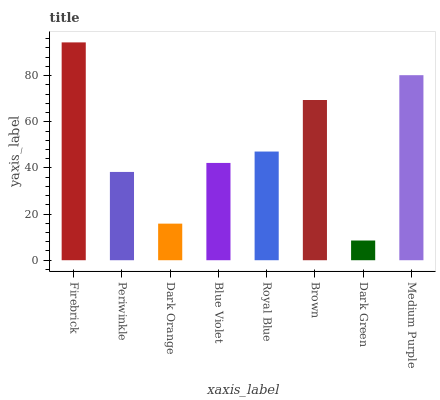Is Dark Green the minimum?
Answer yes or no. Yes. Is Firebrick the maximum?
Answer yes or no. Yes. Is Periwinkle the minimum?
Answer yes or no. No. Is Periwinkle the maximum?
Answer yes or no. No. Is Firebrick greater than Periwinkle?
Answer yes or no. Yes. Is Periwinkle less than Firebrick?
Answer yes or no. Yes. Is Periwinkle greater than Firebrick?
Answer yes or no. No. Is Firebrick less than Periwinkle?
Answer yes or no. No. Is Royal Blue the high median?
Answer yes or no. Yes. Is Blue Violet the low median?
Answer yes or no. Yes. Is Medium Purple the high median?
Answer yes or no. No. Is Dark Green the low median?
Answer yes or no. No. 